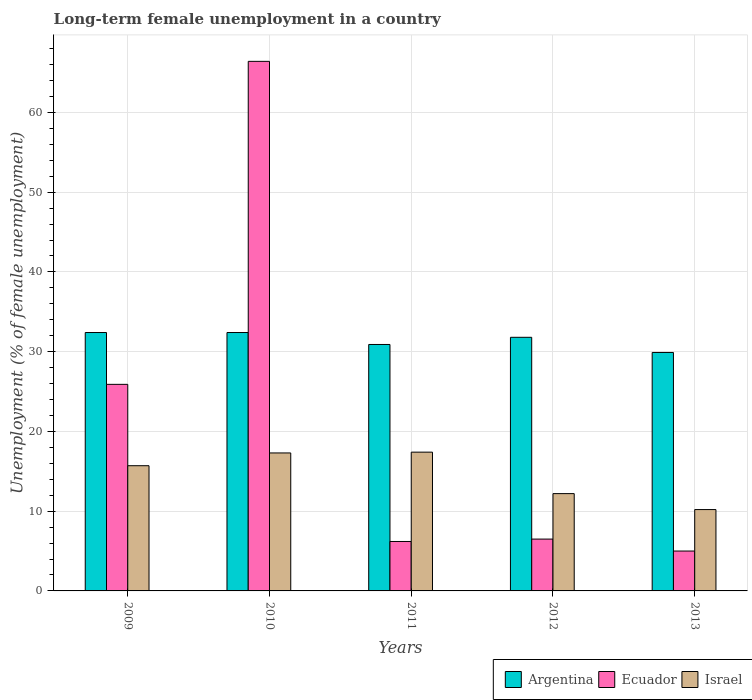How many different coloured bars are there?
Offer a terse response. 3. How many bars are there on the 3rd tick from the left?
Give a very brief answer. 3. How many bars are there on the 5th tick from the right?
Keep it short and to the point. 3. What is the label of the 4th group of bars from the left?
Keep it short and to the point. 2012. In how many cases, is the number of bars for a given year not equal to the number of legend labels?
Offer a terse response. 0. What is the percentage of long-term unemployed female population in Israel in 2012?
Give a very brief answer. 12.2. Across all years, what is the maximum percentage of long-term unemployed female population in Argentina?
Your response must be concise. 32.4. What is the total percentage of long-term unemployed female population in Argentina in the graph?
Ensure brevity in your answer.  157.4. What is the difference between the percentage of long-term unemployed female population in Argentina in 2010 and that in 2011?
Provide a succinct answer. 1.5. What is the difference between the percentage of long-term unemployed female population in Ecuador in 2011 and the percentage of long-term unemployed female population in Argentina in 2009?
Offer a terse response. -26.2. What is the average percentage of long-term unemployed female population in Ecuador per year?
Give a very brief answer. 22. In the year 2012, what is the difference between the percentage of long-term unemployed female population in Ecuador and percentage of long-term unemployed female population in Argentina?
Provide a short and direct response. -25.3. In how many years, is the percentage of long-term unemployed female population in Israel greater than 40 %?
Your answer should be compact. 0. What is the ratio of the percentage of long-term unemployed female population in Ecuador in 2009 to that in 2013?
Offer a very short reply. 5.18. What is the difference between the highest and the second highest percentage of long-term unemployed female population in Ecuador?
Offer a very short reply. 40.5. What is the difference between the highest and the lowest percentage of long-term unemployed female population in Argentina?
Offer a terse response. 2.5. In how many years, is the percentage of long-term unemployed female population in Ecuador greater than the average percentage of long-term unemployed female population in Ecuador taken over all years?
Keep it short and to the point. 2. Is the sum of the percentage of long-term unemployed female population in Ecuador in 2009 and 2012 greater than the maximum percentage of long-term unemployed female population in Argentina across all years?
Offer a very short reply. No. What does the 3rd bar from the left in 2012 represents?
Ensure brevity in your answer.  Israel. What does the 2nd bar from the right in 2009 represents?
Give a very brief answer. Ecuador. Are all the bars in the graph horizontal?
Your response must be concise. No. Does the graph contain any zero values?
Make the answer very short. No. Does the graph contain grids?
Provide a succinct answer. Yes. How are the legend labels stacked?
Keep it short and to the point. Horizontal. What is the title of the graph?
Give a very brief answer. Long-term female unemployment in a country. What is the label or title of the X-axis?
Offer a very short reply. Years. What is the label or title of the Y-axis?
Ensure brevity in your answer.  Unemployment (% of female unemployment). What is the Unemployment (% of female unemployment) in Argentina in 2009?
Keep it short and to the point. 32.4. What is the Unemployment (% of female unemployment) of Ecuador in 2009?
Make the answer very short. 25.9. What is the Unemployment (% of female unemployment) of Israel in 2009?
Ensure brevity in your answer.  15.7. What is the Unemployment (% of female unemployment) of Argentina in 2010?
Give a very brief answer. 32.4. What is the Unemployment (% of female unemployment) of Ecuador in 2010?
Provide a short and direct response. 66.4. What is the Unemployment (% of female unemployment) of Israel in 2010?
Offer a very short reply. 17.3. What is the Unemployment (% of female unemployment) in Argentina in 2011?
Keep it short and to the point. 30.9. What is the Unemployment (% of female unemployment) of Ecuador in 2011?
Keep it short and to the point. 6.2. What is the Unemployment (% of female unemployment) in Israel in 2011?
Keep it short and to the point. 17.4. What is the Unemployment (% of female unemployment) of Argentina in 2012?
Provide a succinct answer. 31.8. What is the Unemployment (% of female unemployment) in Ecuador in 2012?
Make the answer very short. 6.5. What is the Unemployment (% of female unemployment) in Israel in 2012?
Keep it short and to the point. 12.2. What is the Unemployment (% of female unemployment) in Argentina in 2013?
Your response must be concise. 29.9. What is the Unemployment (% of female unemployment) of Israel in 2013?
Provide a short and direct response. 10.2. Across all years, what is the maximum Unemployment (% of female unemployment) of Argentina?
Provide a short and direct response. 32.4. Across all years, what is the maximum Unemployment (% of female unemployment) in Ecuador?
Offer a very short reply. 66.4. Across all years, what is the maximum Unemployment (% of female unemployment) in Israel?
Your answer should be very brief. 17.4. Across all years, what is the minimum Unemployment (% of female unemployment) of Argentina?
Give a very brief answer. 29.9. Across all years, what is the minimum Unemployment (% of female unemployment) in Ecuador?
Give a very brief answer. 5. Across all years, what is the minimum Unemployment (% of female unemployment) in Israel?
Your answer should be very brief. 10.2. What is the total Unemployment (% of female unemployment) of Argentina in the graph?
Your answer should be compact. 157.4. What is the total Unemployment (% of female unemployment) in Ecuador in the graph?
Keep it short and to the point. 110. What is the total Unemployment (% of female unemployment) in Israel in the graph?
Give a very brief answer. 72.8. What is the difference between the Unemployment (% of female unemployment) of Argentina in 2009 and that in 2010?
Your answer should be compact. 0. What is the difference between the Unemployment (% of female unemployment) of Ecuador in 2009 and that in 2010?
Provide a short and direct response. -40.5. What is the difference between the Unemployment (% of female unemployment) of Ecuador in 2009 and that in 2011?
Offer a very short reply. 19.7. What is the difference between the Unemployment (% of female unemployment) of Israel in 2009 and that in 2011?
Provide a succinct answer. -1.7. What is the difference between the Unemployment (% of female unemployment) of Ecuador in 2009 and that in 2012?
Your answer should be very brief. 19.4. What is the difference between the Unemployment (% of female unemployment) in Israel in 2009 and that in 2012?
Keep it short and to the point. 3.5. What is the difference between the Unemployment (% of female unemployment) in Ecuador in 2009 and that in 2013?
Your answer should be compact. 20.9. What is the difference between the Unemployment (% of female unemployment) of Ecuador in 2010 and that in 2011?
Make the answer very short. 60.2. What is the difference between the Unemployment (% of female unemployment) of Argentina in 2010 and that in 2012?
Make the answer very short. 0.6. What is the difference between the Unemployment (% of female unemployment) of Ecuador in 2010 and that in 2012?
Offer a terse response. 59.9. What is the difference between the Unemployment (% of female unemployment) of Israel in 2010 and that in 2012?
Offer a very short reply. 5.1. What is the difference between the Unemployment (% of female unemployment) in Argentina in 2010 and that in 2013?
Provide a short and direct response. 2.5. What is the difference between the Unemployment (% of female unemployment) of Ecuador in 2010 and that in 2013?
Your answer should be very brief. 61.4. What is the difference between the Unemployment (% of female unemployment) of Israel in 2010 and that in 2013?
Give a very brief answer. 7.1. What is the difference between the Unemployment (% of female unemployment) of Argentina in 2011 and that in 2012?
Give a very brief answer. -0.9. What is the difference between the Unemployment (% of female unemployment) of Ecuador in 2011 and that in 2012?
Your answer should be compact. -0.3. What is the difference between the Unemployment (% of female unemployment) in Argentina in 2011 and that in 2013?
Give a very brief answer. 1. What is the difference between the Unemployment (% of female unemployment) in Ecuador in 2011 and that in 2013?
Keep it short and to the point. 1.2. What is the difference between the Unemployment (% of female unemployment) in Israel in 2012 and that in 2013?
Keep it short and to the point. 2. What is the difference between the Unemployment (% of female unemployment) in Argentina in 2009 and the Unemployment (% of female unemployment) in Ecuador in 2010?
Give a very brief answer. -34. What is the difference between the Unemployment (% of female unemployment) of Argentina in 2009 and the Unemployment (% of female unemployment) of Israel in 2010?
Make the answer very short. 15.1. What is the difference between the Unemployment (% of female unemployment) in Argentina in 2009 and the Unemployment (% of female unemployment) in Ecuador in 2011?
Provide a succinct answer. 26.2. What is the difference between the Unemployment (% of female unemployment) in Ecuador in 2009 and the Unemployment (% of female unemployment) in Israel in 2011?
Offer a terse response. 8.5. What is the difference between the Unemployment (% of female unemployment) in Argentina in 2009 and the Unemployment (% of female unemployment) in Ecuador in 2012?
Your answer should be compact. 25.9. What is the difference between the Unemployment (% of female unemployment) in Argentina in 2009 and the Unemployment (% of female unemployment) in Israel in 2012?
Make the answer very short. 20.2. What is the difference between the Unemployment (% of female unemployment) in Argentina in 2009 and the Unemployment (% of female unemployment) in Ecuador in 2013?
Your response must be concise. 27.4. What is the difference between the Unemployment (% of female unemployment) in Argentina in 2009 and the Unemployment (% of female unemployment) in Israel in 2013?
Give a very brief answer. 22.2. What is the difference between the Unemployment (% of female unemployment) of Argentina in 2010 and the Unemployment (% of female unemployment) of Ecuador in 2011?
Ensure brevity in your answer.  26.2. What is the difference between the Unemployment (% of female unemployment) of Argentina in 2010 and the Unemployment (% of female unemployment) of Israel in 2011?
Give a very brief answer. 15. What is the difference between the Unemployment (% of female unemployment) of Argentina in 2010 and the Unemployment (% of female unemployment) of Ecuador in 2012?
Your answer should be very brief. 25.9. What is the difference between the Unemployment (% of female unemployment) in Argentina in 2010 and the Unemployment (% of female unemployment) in Israel in 2012?
Provide a short and direct response. 20.2. What is the difference between the Unemployment (% of female unemployment) in Ecuador in 2010 and the Unemployment (% of female unemployment) in Israel in 2012?
Keep it short and to the point. 54.2. What is the difference between the Unemployment (% of female unemployment) in Argentina in 2010 and the Unemployment (% of female unemployment) in Ecuador in 2013?
Offer a very short reply. 27.4. What is the difference between the Unemployment (% of female unemployment) of Argentina in 2010 and the Unemployment (% of female unemployment) of Israel in 2013?
Give a very brief answer. 22.2. What is the difference between the Unemployment (% of female unemployment) in Ecuador in 2010 and the Unemployment (% of female unemployment) in Israel in 2013?
Provide a short and direct response. 56.2. What is the difference between the Unemployment (% of female unemployment) in Argentina in 2011 and the Unemployment (% of female unemployment) in Ecuador in 2012?
Provide a succinct answer. 24.4. What is the difference between the Unemployment (% of female unemployment) of Ecuador in 2011 and the Unemployment (% of female unemployment) of Israel in 2012?
Provide a succinct answer. -6. What is the difference between the Unemployment (% of female unemployment) in Argentina in 2011 and the Unemployment (% of female unemployment) in Ecuador in 2013?
Provide a succinct answer. 25.9. What is the difference between the Unemployment (% of female unemployment) in Argentina in 2011 and the Unemployment (% of female unemployment) in Israel in 2013?
Offer a terse response. 20.7. What is the difference between the Unemployment (% of female unemployment) in Ecuador in 2011 and the Unemployment (% of female unemployment) in Israel in 2013?
Keep it short and to the point. -4. What is the difference between the Unemployment (% of female unemployment) of Argentina in 2012 and the Unemployment (% of female unemployment) of Ecuador in 2013?
Provide a short and direct response. 26.8. What is the difference between the Unemployment (% of female unemployment) of Argentina in 2012 and the Unemployment (% of female unemployment) of Israel in 2013?
Your answer should be compact. 21.6. What is the difference between the Unemployment (% of female unemployment) of Ecuador in 2012 and the Unemployment (% of female unemployment) of Israel in 2013?
Provide a short and direct response. -3.7. What is the average Unemployment (% of female unemployment) of Argentina per year?
Provide a short and direct response. 31.48. What is the average Unemployment (% of female unemployment) in Ecuador per year?
Give a very brief answer. 22. What is the average Unemployment (% of female unemployment) in Israel per year?
Your answer should be compact. 14.56. In the year 2009, what is the difference between the Unemployment (% of female unemployment) of Argentina and Unemployment (% of female unemployment) of Ecuador?
Offer a very short reply. 6.5. In the year 2009, what is the difference between the Unemployment (% of female unemployment) of Argentina and Unemployment (% of female unemployment) of Israel?
Keep it short and to the point. 16.7. In the year 2010, what is the difference between the Unemployment (% of female unemployment) in Argentina and Unemployment (% of female unemployment) in Ecuador?
Give a very brief answer. -34. In the year 2010, what is the difference between the Unemployment (% of female unemployment) of Argentina and Unemployment (% of female unemployment) of Israel?
Give a very brief answer. 15.1. In the year 2010, what is the difference between the Unemployment (% of female unemployment) of Ecuador and Unemployment (% of female unemployment) of Israel?
Make the answer very short. 49.1. In the year 2011, what is the difference between the Unemployment (% of female unemployment) in Argentina and Unemployment (% of female unemployment) in Ecuador?
Offer a terse response. 24.7. In the year 2011, what is the difference between the Unemployment (% of female unemployment) of Argentina and Unemployment (% of female unemployment) of Israel?
Your answer should be very brief. 13.5. In the year 2011, what is the difference between the Unemployment (% of female unemployment) of Ecuador and Unemployment (% of female unemployment) of Israel?
Your answer should be compact. -11.2. In the year 2012, what is the difference between the Unemployment (% of female unemployment) in Argentina and Unemployment (% of female unemployment) in Ecuador?
Make the answer very short. 25.3. In the year 2012, what is the difference between the Unemployment (% of female unemployment) of Argentina and Unemployment (% of female unemployment) of Israel?
Provide a succinct answer. 19.6. In the year 2013, what is the difference between the Unemployment (% of female unemployment) in Argentina and Unemployment (% of female unemployment) in Ecuador?
Provide a succinct answer. 24.9. In the year 2013, what is the difference between the Unemployment (% of female unemployment) in Argentina and Unemployment (% of female unemployment) in Israel?
Provide a short and direct response. 19.7. In the year 2013, what is the difference between the Unemployment (% of female unemployment) of Ecuador and Unemployment (% of female unemployment) of Israel?
Provide a succinct answer. -5.2. What is the ratio of the Unemployment (% of female unemployment) in Ecuador in 2009 to that in 2010?
Keep it short and to the point. 0.39. What is the ratio of the Unemployment (% of female unemployment) in Israel in 2009 to that in 2010?
Your response must be concise. 0.91. What is the ratio of the Unemployment (% of female unemployment) in Argentina in 2009 to that in 2011?
Ensure brevity in your answer.  1.05. What is the ratio of the Unemployment (% of female unemployment) in Ecuador in 2009 to that in 2011?
Your answer should be compact. 4.18. What is the ratio of the Unemployment (% of female unemployment) of Israel in 2009 to that in 2011?
Give a very brief answer. 0.9. What is the ratio of the Unemployment (% of female unemployment) of Argentina in 2009 to that in 2012?
Your answer should be compact. 1.02. What is the ratio of the Unemployment (% of female unemployment) of Ecuador in 2009 to that in 2012?
Offer a very short reply. 3.98. What is the ratio of the Unemployment (% of female unemployment) of Israel in 2009 to that in 2012?
Your response must be concise. 1.29. What is the ratio of the Unemployment (% of female unemployment) of Argentina in 2009 to that in 2013?
Ensure brevity in your answer.  1.08. What is the ratio of the Unemployment (% of female unemployment) of Ecuador in 2009 to that in 2013?
Offer a terse response. 5.18. What is the ratio of the Unemployment (% of female unemployment) in Israel in 2009 to that in 2013?
Your response must be concise. 1.54. What is the ratio of the Unemployment (% of female unemployment) of Argentina in 2010 to that in 2011?
Ensure brevity in your answer.  1.05. What is the ratio of the Unemployment (% of female unemployment) of Ecuador in 2010 to that in 2011?
Give a very brief answer. 10.71. What is the ratio of the Unemployment (% of female unemployment) of Argentina in 2010 to that in 2012?
Your answer should be compact. 1.02. What is the ratio of the Unemployment (% of female unemployment) of Ecuador in 2010 to that in 2012?
Your response must be concise. 10.22. What is the ratio of the Unemployment (% of female unemployment) of Israel in 2010 to that in 2012?
Ensure brevity in your answer.  1.42. What is the ratio of the Unemployment (% of female unemployment) of Argentina in 2010 to that in 2013?
Keep it short and to the point. 1.08. What is the ratio of the Unemployment (% of female unemployment) in Ecuador in 2010 to that in 2013?
Your answer should be compact. 13.28. What is the ratio of the Unemployment (% of female unemployment) of Israel in 2010 to that in 2013?
Ensure brevity in your answer.  1.7. What is the ratio of the Unemployment (% of female unemployment) in Argentina in 2011 to that in 2012?
Ensure brevity in your answer.  0.97. What is the ratio of the Unemployment (% of female unemployment) in Ecuador in 2011 to that in 2012?
Give a very brief answer. 0.95. What is the ratio of the Unemployment (% of female unemployment) of Israel in 2011 to that in 2012?
Offer a terse response. 1.43. What is the ratio of the Unemployment (% of female unemployment) of Argentina in 2011 to that in 2013?
Provide a succinct answer. 1.03. What is the ratio of the Unemployment (% of female unemployment) of Ecuador in 2011 to that in 2013?
Offer a very short reply. 1.24. What is the ratio of the Unemployment (% of female unemployment) of Israel in 2011 to that in 2013?
Keep it short and to the point. 1.71. What is the ratio of the Unemployment (% of female unemployment) of Argentina in 2012 to that in 2013?
Your answer should be very brief. 1.06. What is the ratio of the Unemployment (% of female unemployment) in Ecuador in 2012 to that in 2013?
Offer a very short reply. 1.3. What is the ratio of the Unemployment (% of female unemployment) of Israel in 2012 to that in 2013?
Ensure brevity in your answer.  1.2. What is the difference between the highest and the second highest Unemployment (% of female unemployment) in Ecuador?
Keep it short and to the point. 40.5. What is the difference between the highest and the lowest Unemployment (% of female unemployment) of Argentina?
Your answer should be very brief. 2.5. What is the difference between the highest and the lowest Unemployment (% of female unemployment) in Ecuador?
Give a very brief answer. 61.4. What is the difference between the highest and the lowest Unemployment (% of female unemployment) in Israel?
Your answer should be compact. 7.2. 